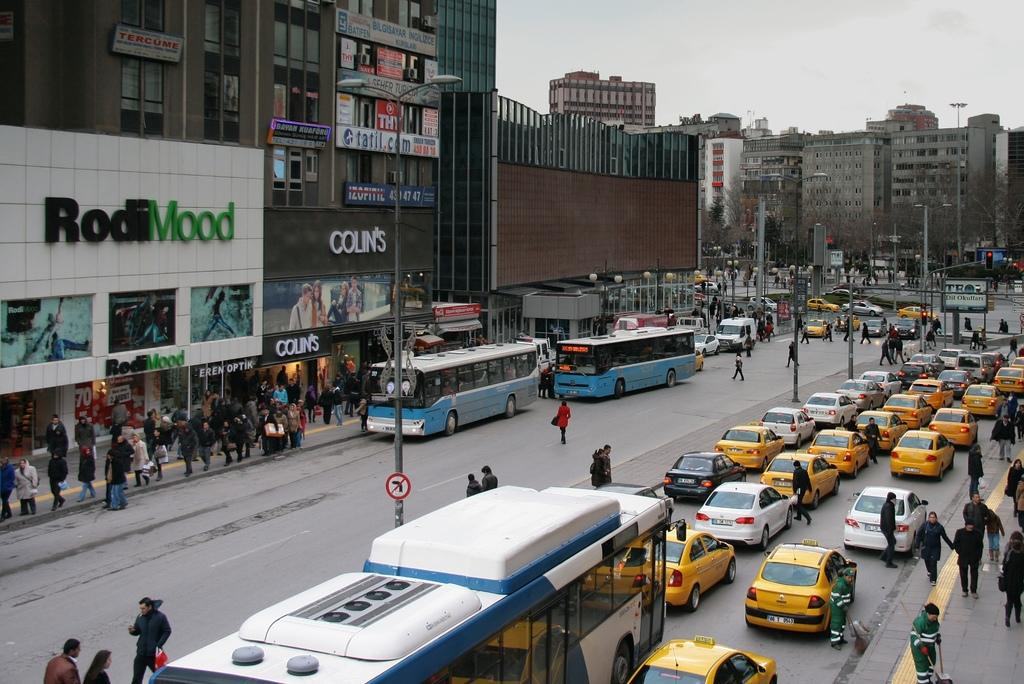<image>
Create a compact narrative representing the image presented. A busy street with the RodiMood building visible in the background. 